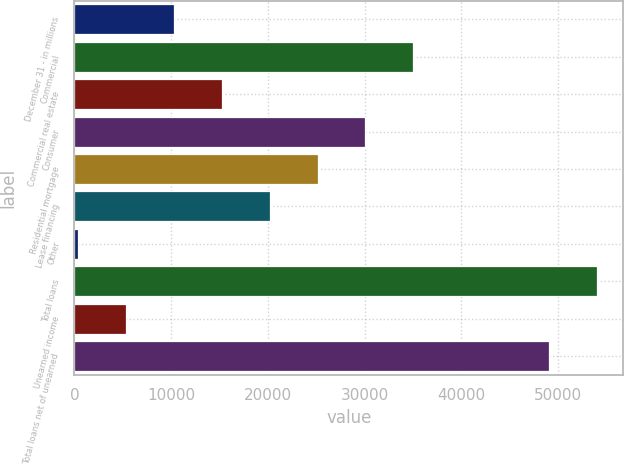<chart> <loc_0><loc_0><loc_500><loc_500><bar_chart><fcel>December 31 - in millions<fcel>Commercial<fcel>Commercial real estate<fcel>Consumer<fcel>Residential mortgage<fcel>Lease financing<fcel>Other<fcel>Total loans<fcel>Unearned income<fcel>Total loans net of unearned<nl><fcel>10260<fcel>35057.5<fcel>15219.5<fcel>30098<fcel>25138.5<fcel>20179<fcel>341<fcel>54060.5<fcel>5300.5<fcel>49101<nl></chart> 